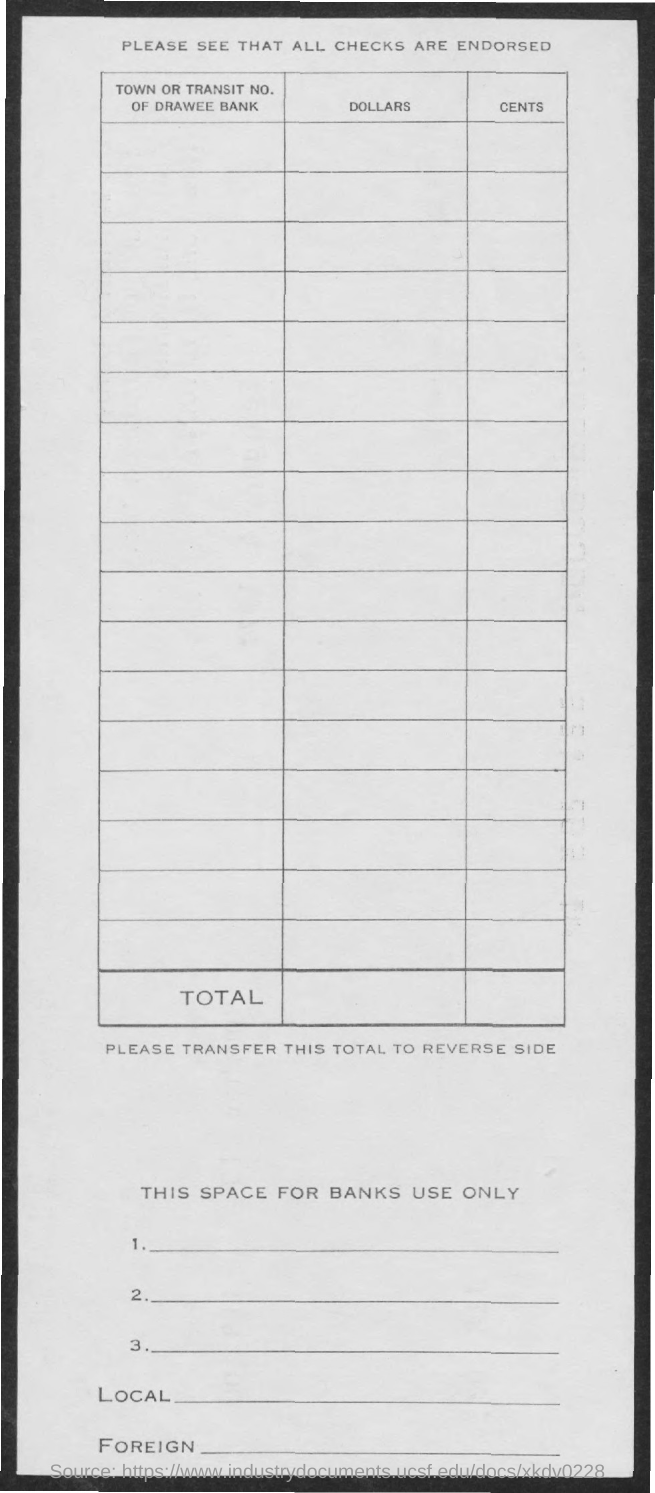Indicate a few pertinent items in this graphic. The second column is titled "Dollars. The third column contains the word "Cents. 